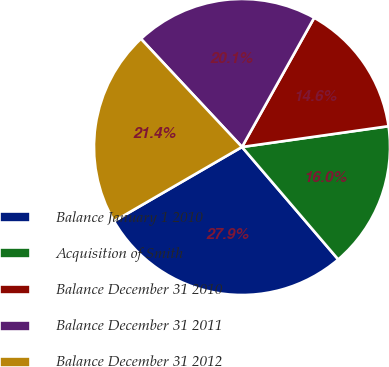Convert chart to OTSL. <chart><loc_0><loc_0><loc_500><loc_500><pie_chart><fcel>Balance January 1 2010<fcel>Acquisition of Smith<fcel>Balance December 31 2010<fcel>Balance December 31 2011<fcel>Balance December 31 2012<nl><fcel>27.9%<fcel>15.98%<fcel>14.65%<fcel>20.07%<fcel>21.4%<nl></chart> 